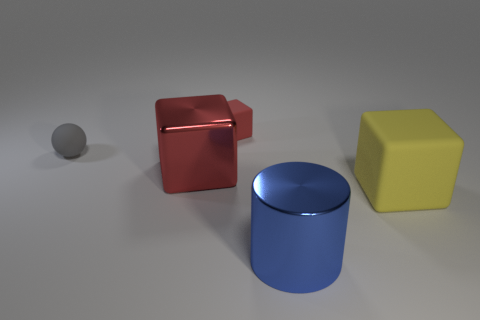There is a object that is the same color as the metallic block; what is it made of?
Keep it short and to the point. Rubber. The blue thing that is the same size as the yellow cube is what shape?
Offer a very short reply. Cylinder. There is a object that is on the right side of the cylinder; what color is it?
Give a very brief answer. Yellow. Is there a small rubber thing behind the cube behind the tiny gray matte object?
Offer a very short reply. No. How many things are cubes that are to the right of the small block or big blue metallic cylinders?
Your answer should be compact. 2. Is there anything else that has the same size as the yellow cube?
Offer a very short reply. Yes. The red cube that is behind the large thing that is behind the yellow thing is made of what material?
Provide a succinct answer. Rubber. Is the number of shiny cubes that are behind the large red thing the same as the number of matte blocks that are in front of the small red thing?
Your answer should be very brief. No. How many things are cubes to the right of the large shiny cylinder or cubes in front of the red matte cube?
Your answer should be compact. 2. There is a block that is in front of the tiny red rubber cube and behind the large yellow block; what is its material?
Make the answer very short. Metal. 